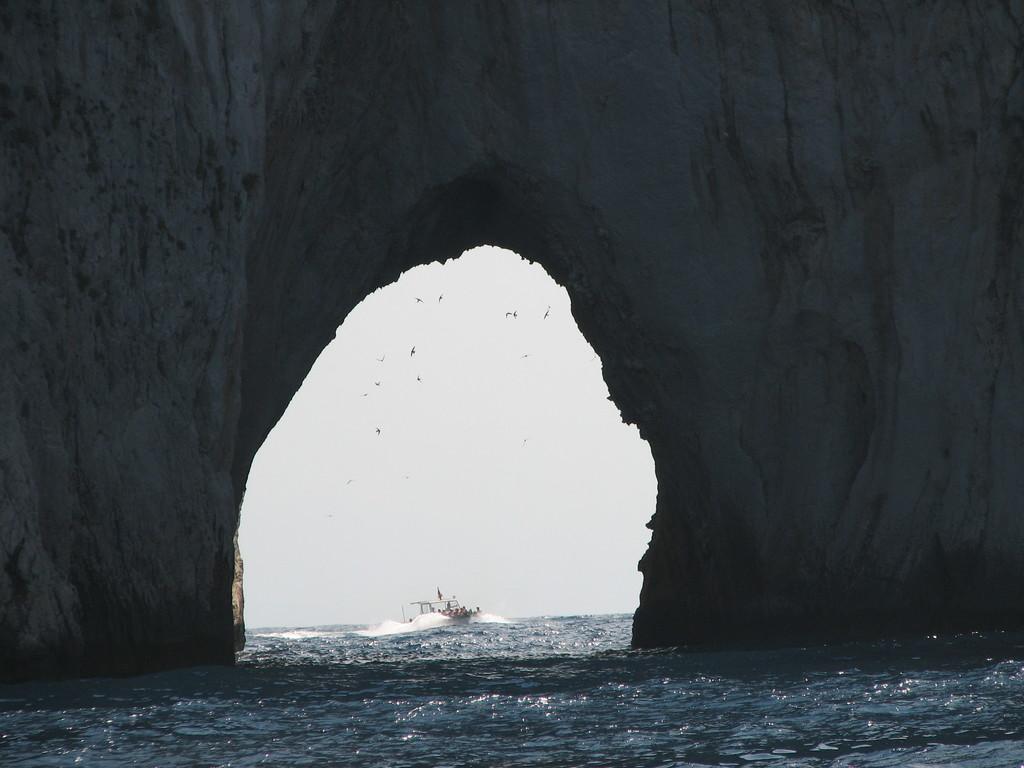Can you describe this image briefly? In this image we can see tunnel, boat, birds, sky and water. 